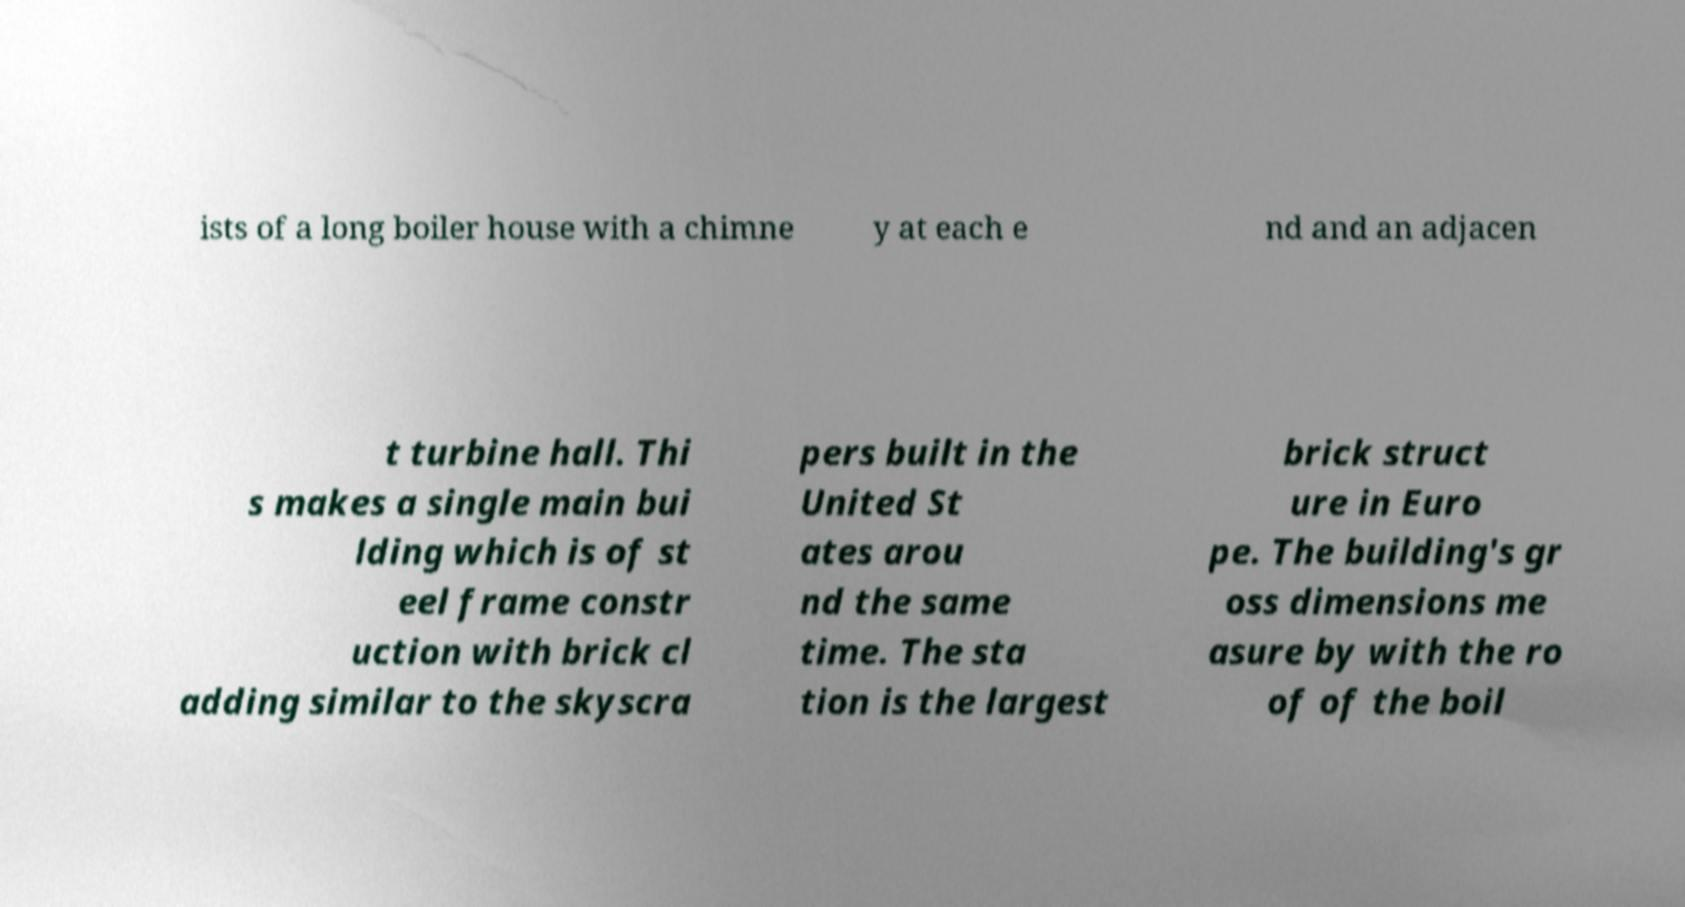I need the written content from this picture converted into text. Can you do that? ists of a long boiler house with a chimne y at each e nd and an adjacen t turbine hall. Thi s makes a single main bui lding which is of st eel frame constr uction with brick cl adding similar to the skyscra pers built in the United St ates arou nd the same time. The sta tion is the largest brick struct ure in Euro pe. The building's gr oss dimensions me asure by with the ro of of the boil 